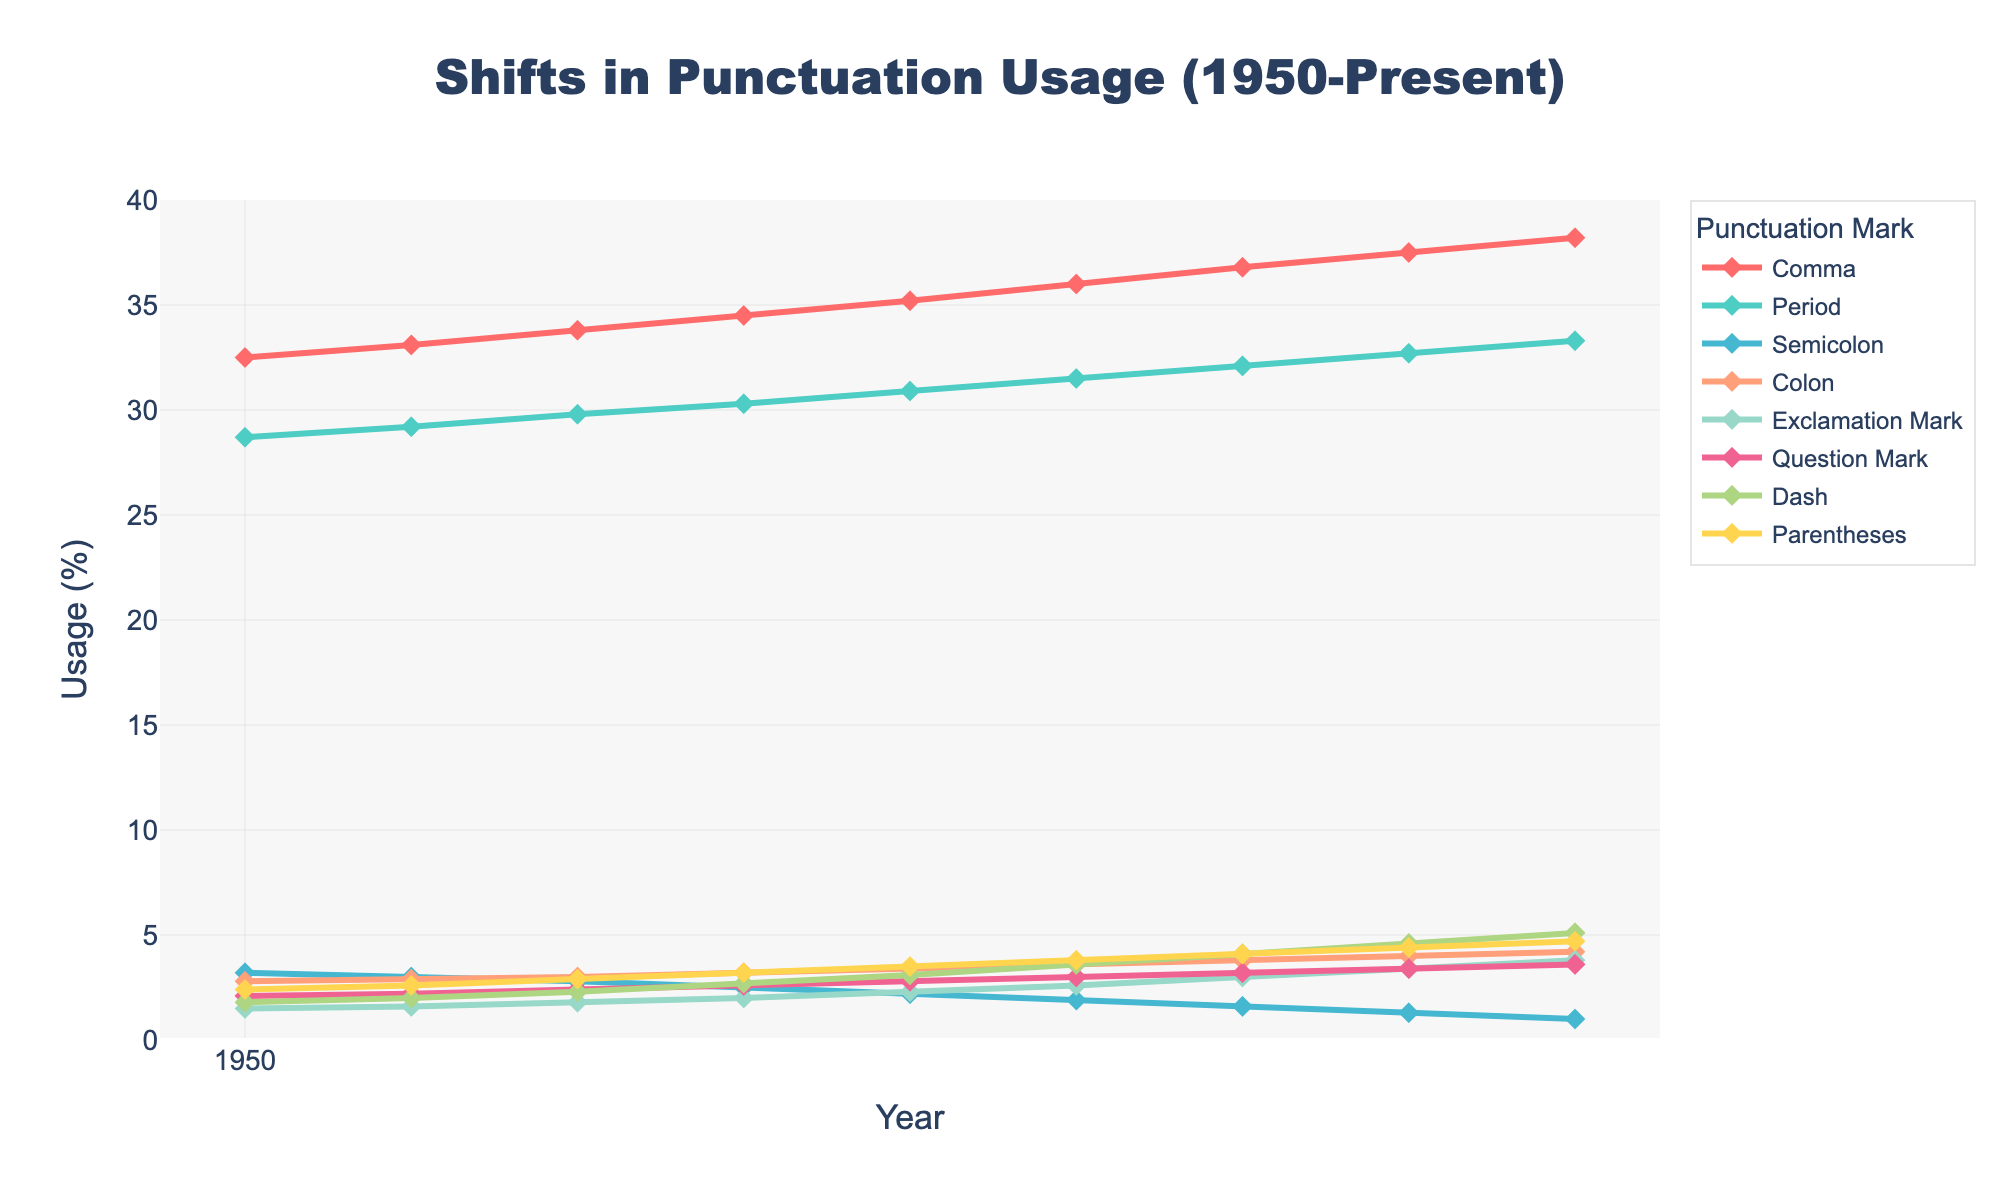What punctuation mark has the highest usage rate in the present year? By looking at the end of the chart (present year), the line that is highest represents the punctuation mark with the highest usage rate. The line representing the comma is at the highest position.
Answer: Comma How has the usage of the semicolon changed from 1950 to the present day? Identify the starting and ending points of the semicolon line on the chart. In 1950, it starts at 3.2% and decreases to 1.0% in the present day.
Answer: Decreased What is the trend in the usage of the colon from 1950 to the present day? Examine the line corresponding to the colon from 1950 to the present year. It shows an upward trend, starting at 2.8% in 1950 and increasing to 4.2% in the present day.
Answer: Increasing Which punctuation marks display an increasing trend over the years? Look for lines that show an upward trajectory. The comma, period, colon, exclamation mark, question mark, dash, and parentheses all show increasing trends.
Answer: Comma, Period, Colon, Exclamation Mark, Question Mark, Dash, Parentheses Compare the usage of the period and the comma in the year 2000. Which was used more? Refer to the year 2000 on the x-axis and compare the heights of the lines corresponding to the period and comma. The comma line is higher than the period line in 2000 (36.0% vs. 31.5%).
Answer: Comma By how much has the usage of the dash increased from 1950 to the present day? Calculate the difference between the usage in 1950 (1.8%) and the present day (5.1%) for the dash. The increase is 5.1% - 1.8% = 3.3%.
Answer: 3.3% Which punctuation had the smallest usage rate in 1990? Look at the data points for 1990 and compare the lines' positions. The semicolon has the lowest usage rate in 1990 at 2.2%.
Answer: Semicolon Did the usage of parentheses ever exceed that of the dash? Compare the positions of the lines representing parentheses and the dash over the years. They cross each other around 1960 but diverge again with the dash rising more steeply.
Answer: No What is the average usage rate of the exclamation mark from 1950 to 2020? Summing up the usage rates of the exclamation mark from all years and dividing by the number of years: (1.5 + 1.6 + 1.8 + 2.0 + 2.3 + 2.6 + 3.0 + 3.4 + 3.8)/9 = 2.67%.
Answer: 2.67% In which year did the question mark usage surpass 3% for the first time? Trace the line for the question mark to find when it first rises above the 3% value. It first surpasses 3% in 2010.
Answer: 2010 